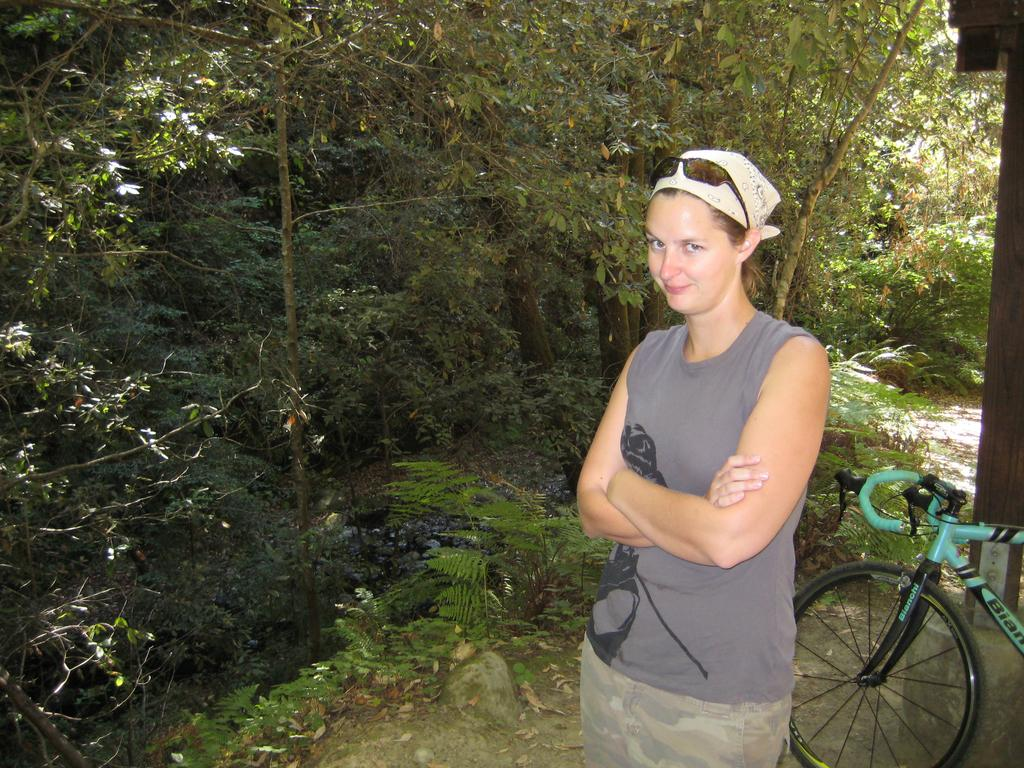What is the main subject of the image? There is a woman standing in the image. What object is located on the side of the image? There is a bicycle on the side of the image. What type of natural elements can be seen in the image? Trees and plants are visible in the image. What type of government is depicted in the image? There is no depiction of a government in the image; it features a woman standing, a bicycle, trees, and plants. How many wings can be seen on the woman in the image? The woman in the image does not have any wings; she is a regular human. 